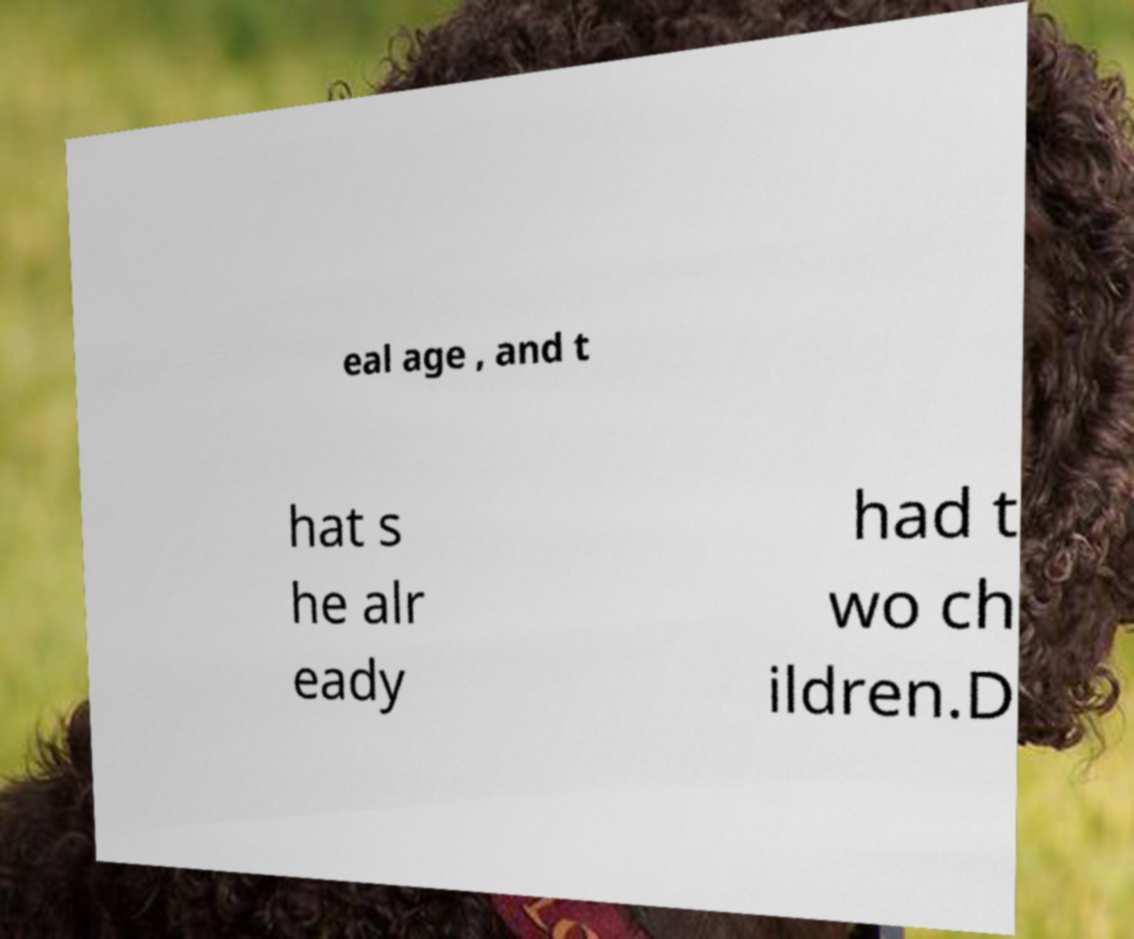Could you assist in decoding the text presented in this image and type it out clearly? eal age , and t hat s he alr eady had t wo ch ildren.D 